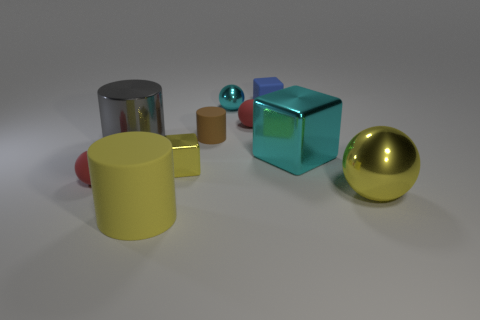Subtract all rubber cylinders. How many cylinders are left? 1 Subtract all yellow cubes. How many cubes are left? 2 Subtract all balls. How many objects are left? 6 Subtract all yellow balls. How many gray cubes are left? 0 Subtract 2 balls. How many balls are left? 2 Subtract all yellow balls. Subtract all green cylinders. How many balls are left? 3 Subtract all big rubber objects. Subtract all tiny brown rubber cylinders. How many objects are left? 8 Add 7 brown rubber cylinders. How many brown rubber cylinders are left? 8 Add 2 cubes. How many cubes exist? 5 Subtract 1 blue blocks. How many objects are left? 9 